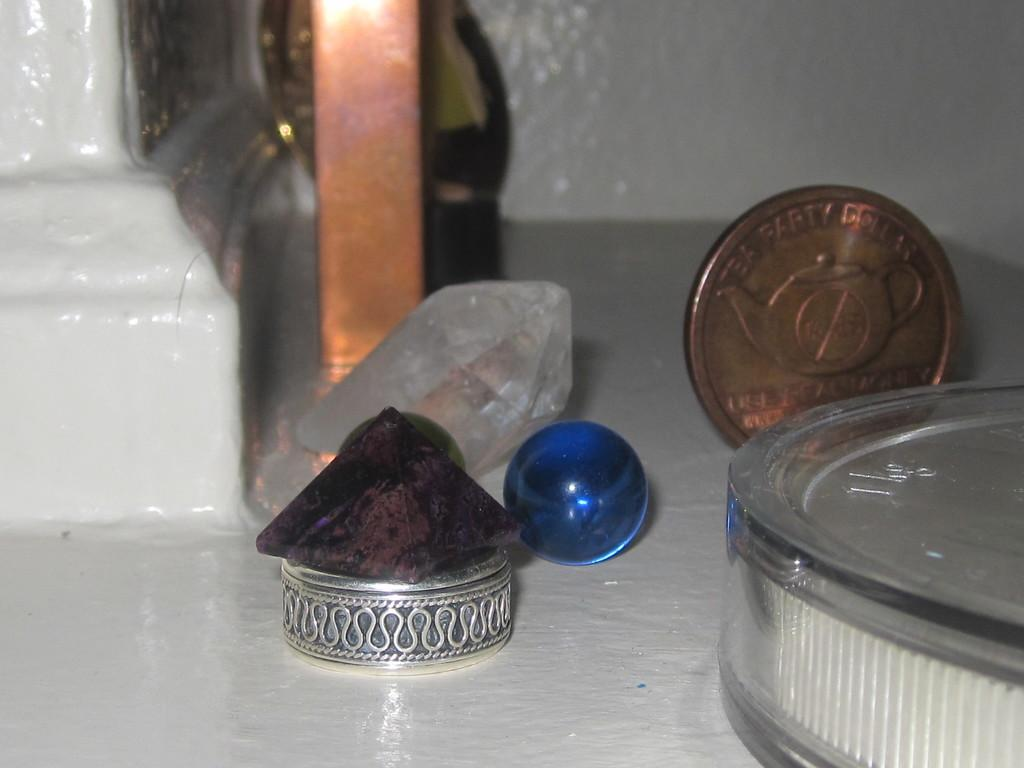<image>
Render a clear and concise summary of the photo. A small silver tin, a marble, a Tea Party coin and container are on a counter. 